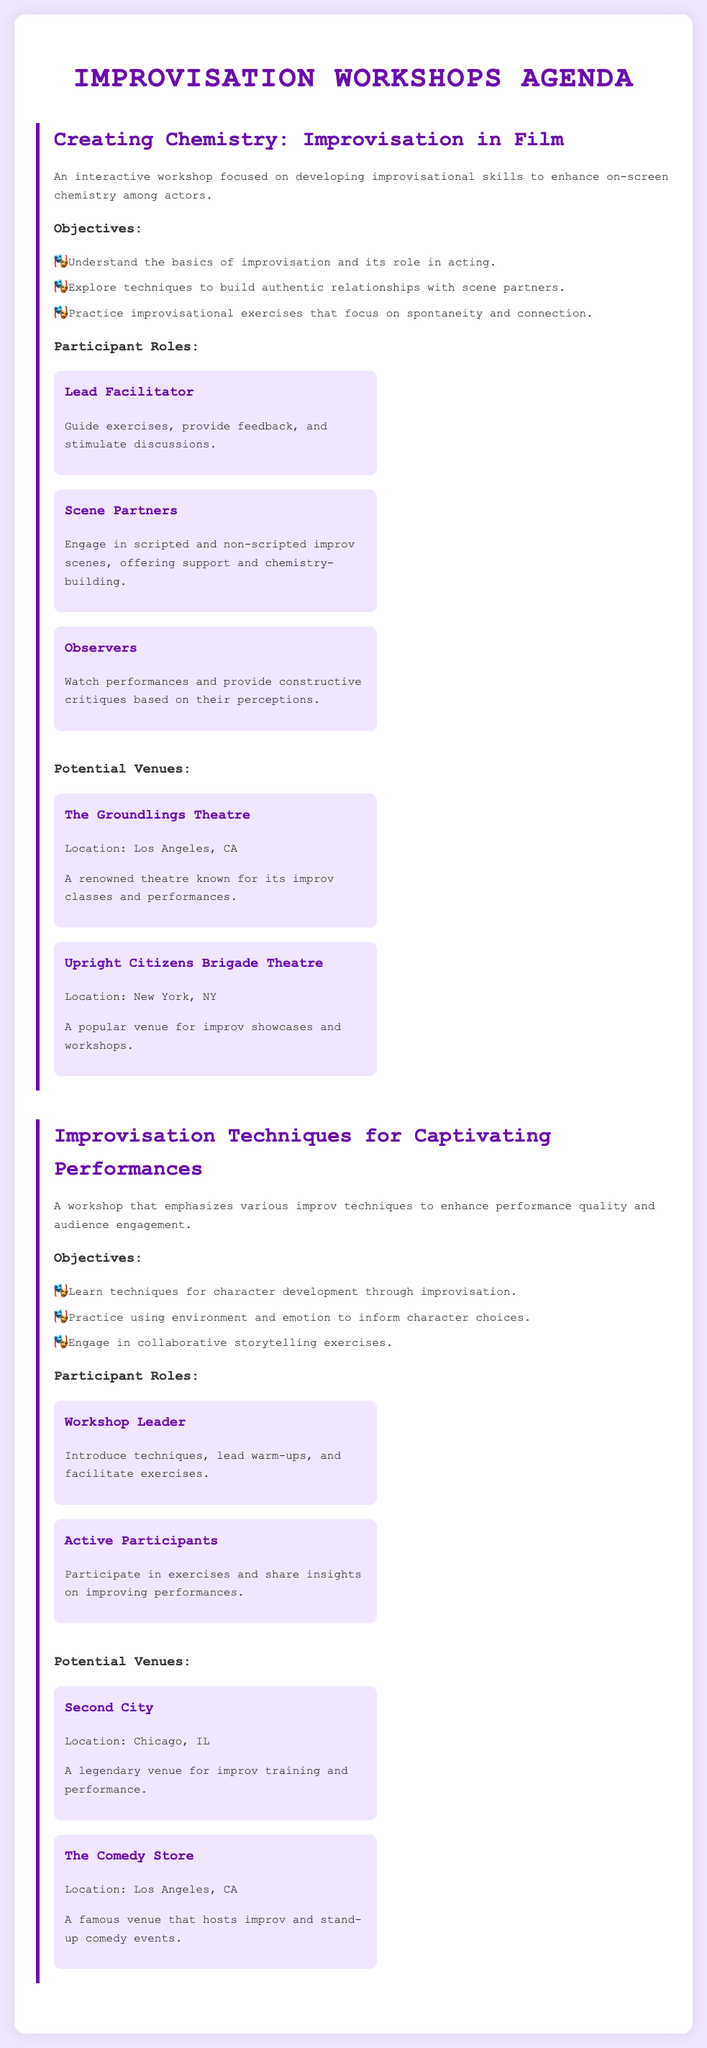What is the title of the first workshop? The title of the first workshop is presented in the document under the workshop section.
Answer: Creating Chemistry: Improvisation in Film How many participant roles are listed in the first workshop? The document specifies three distinct roles for participants in the first workshop.
Answer: Three What are the potential venues for the second workshop? The venues are detailed in the document under the second workshop section.
Answer: Second City, The Comedy Store What is the location of The Groundlings Theatre? The document contains the location details for The Groundlings Theatre under the potential venues section.
Answer: Los Angeles, CA Who leads the exercises in the first workshop? The document references the lead facilitator responsible for guiding exercises in the first workshop.
Answer: Lead Facilitator What is the objective of the second workshop regarding character development? The document outlines specific workshop objectives, including techniques for character development in the second workshop.
Answer: Learn techniques for character development through improvisation How many workshops are listed in the document? The count of workshops is derived from the listed sections in the document.
Answer: Two What type of theatre is the Upright Citizens Brigade Theatre? The document describes the Upright Citizens Brigade Theatre under the potential venues reference.
Answer: A popular venue for improv showcases and workshops 